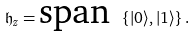<formula> <loc_0><loc_0><loc_500><loc_500>\mathfrak { h } _ { z } = \text {span } \left \{ | 0 \rangle , | 1 \rangle \right \} .</formula> 